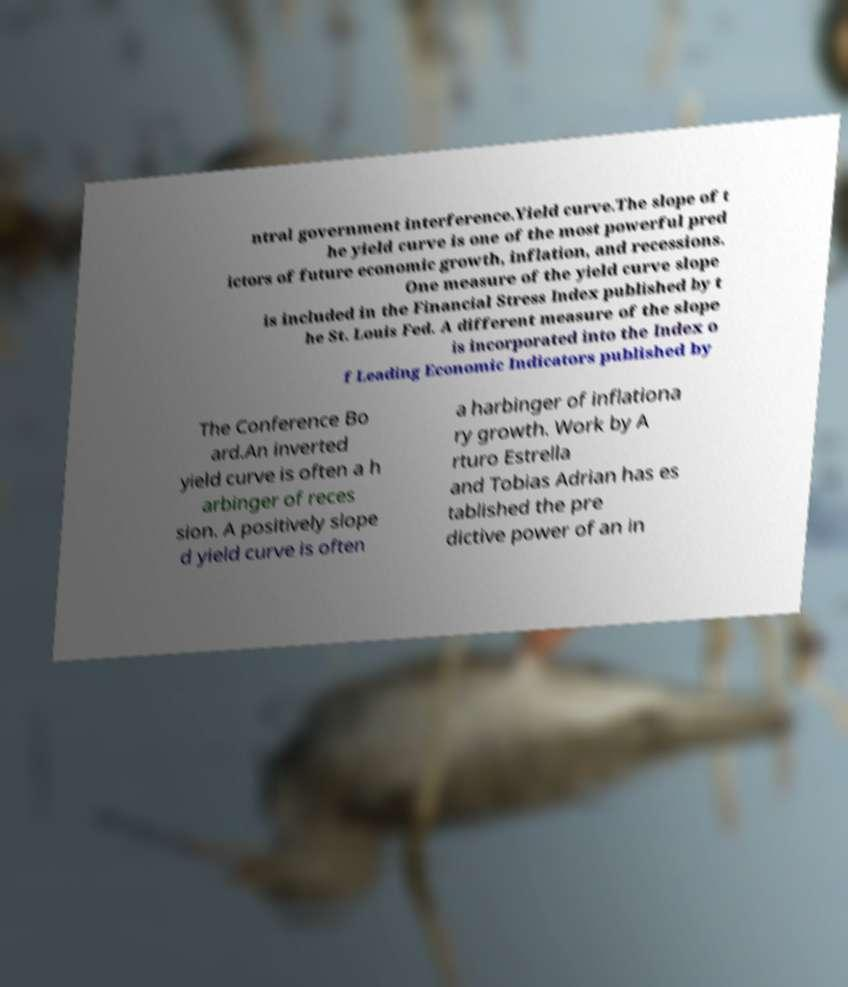Please read and relay the text visible in this image. What does it say? ntral government interference.Yield curve.The slope of t he yield curve is one of the most powerful pred ictors of future economic growth, inflation, and recessions. One measure of the yield curve slope is included in the Financial Stress Index published by t he St. Louis Fed. A different measure of the slope is incorporated into the Index o f Leading Economic Indicators published by The Conference Bo ard.An inverted yield curve is often a h arbinger of reces sion. A positively slope d yield curve is often a harbinger of inflationa ry growth. Work by A rturo Estrella and Tobias Adrian has es tablished the pre dictive power of an in 